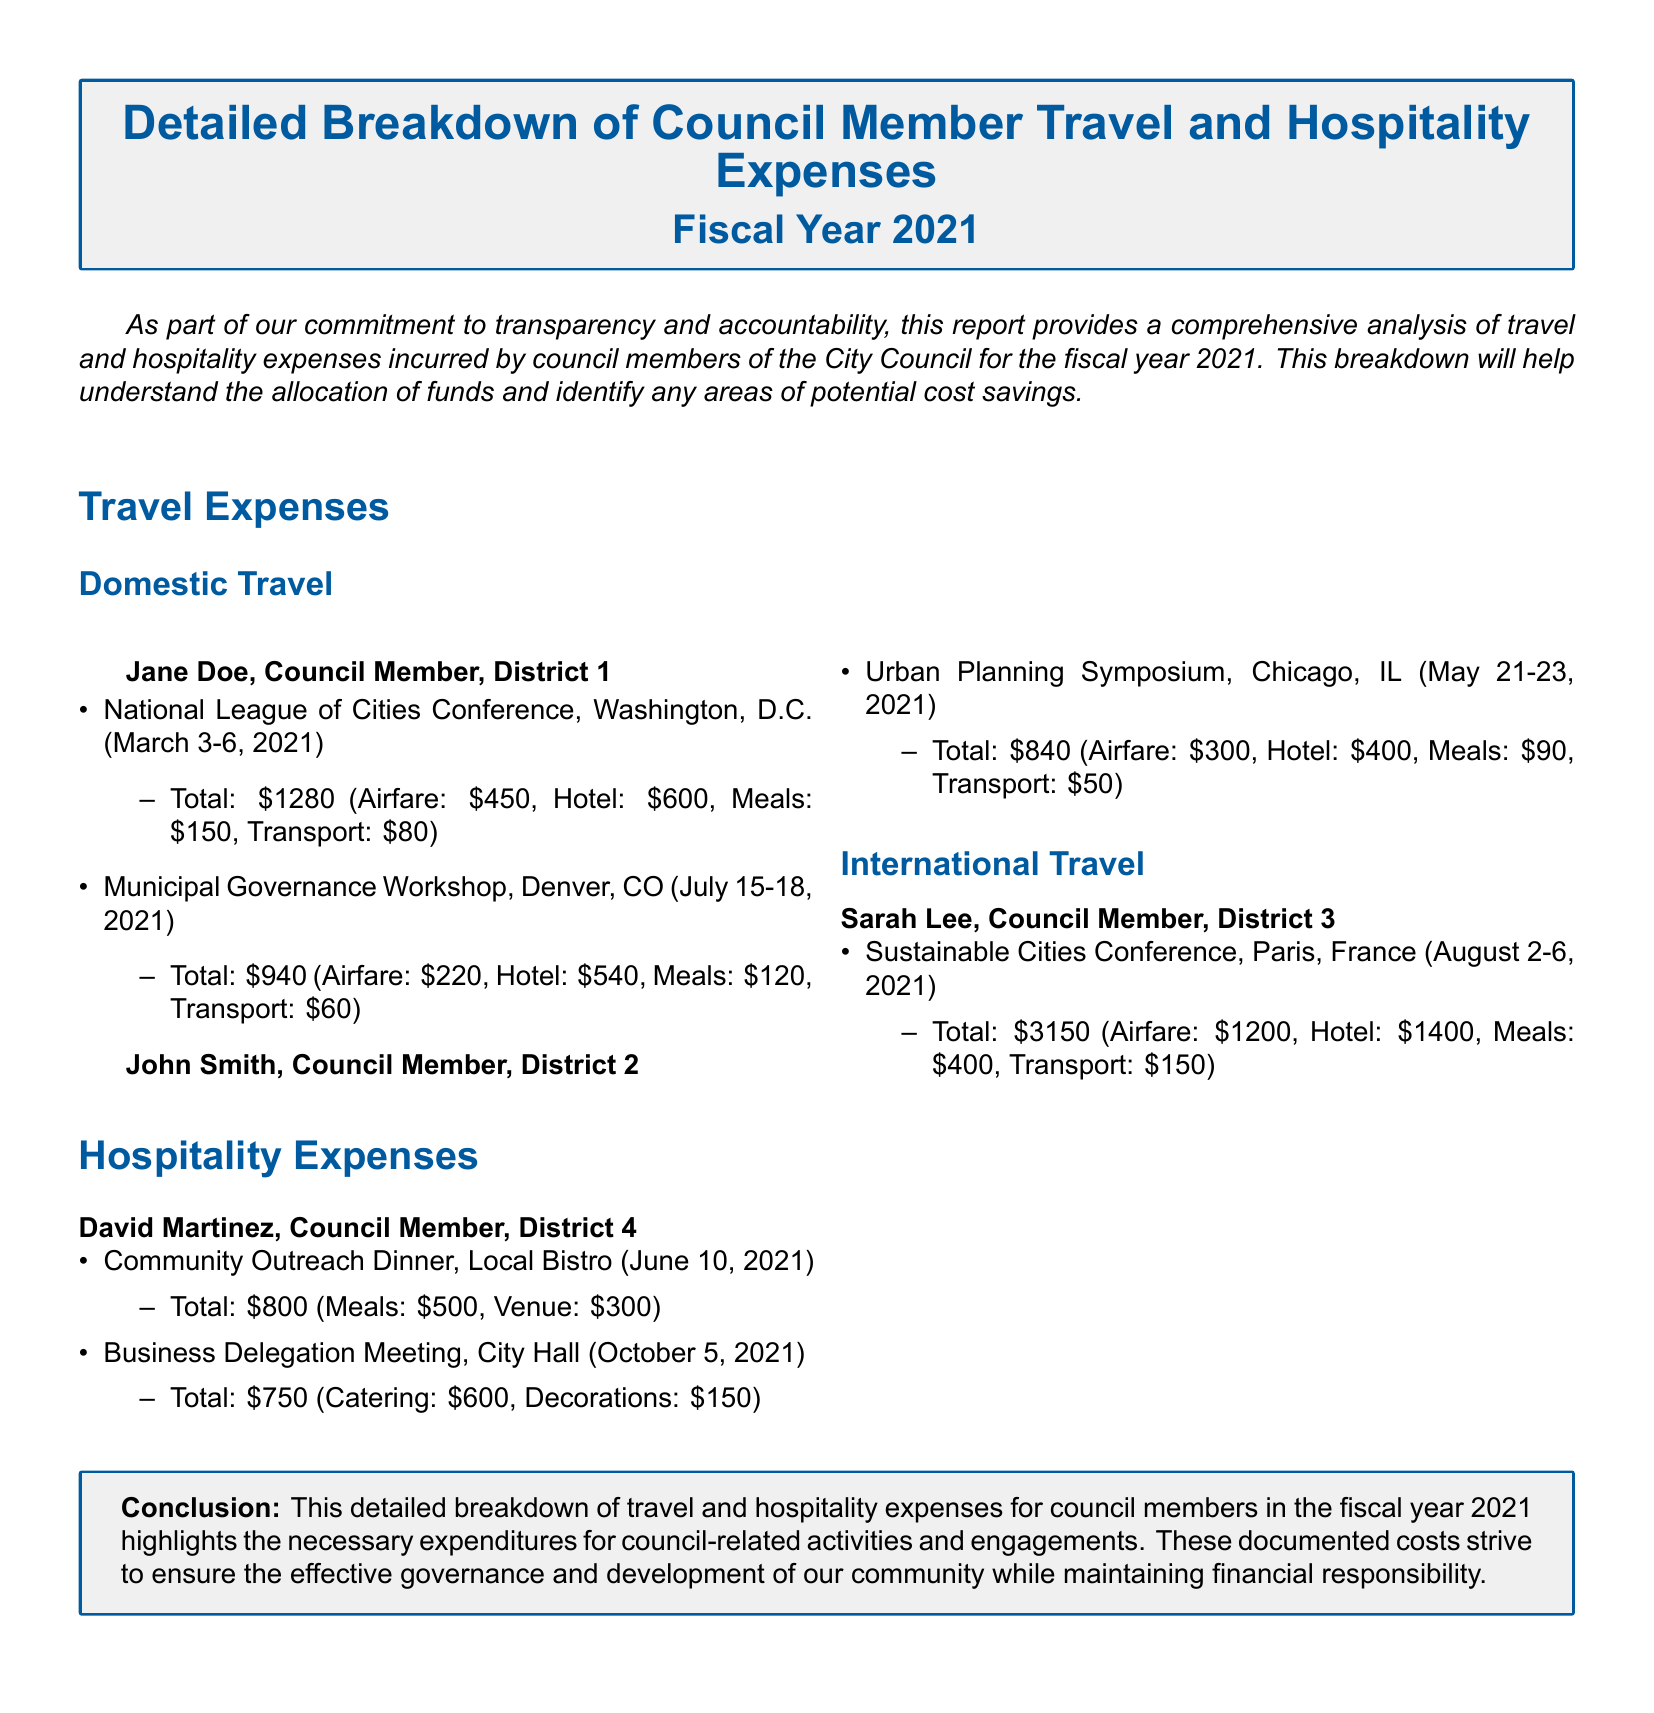What was the total amount spent by Jane Doe on domestic travel? The total amount spent by Jane Doe on domestic travel is the sum of her two listed trips: $1280 (National League of Cities Conference) + $940 (Municipal Governance Workshop) = $2220.
Answer: $2220 What was the airfare cost for Sarah Lee's trip? The airfare cost for Sarah Lee's trip to the Sustainable Cities Conference is stated as $1200.
Answer: $1200 How many council members are mentioned in the report? The report mentions four council members: Jane Doe, John Smith, Sarah Lee, and David Martinez.
Answer: Four What was the total cost for David Martinez's Community Outreach Dinner? The total cost for David Martinez's Community Outreach Dinner is $800, as outlined in the hospitality expenses section.
Answer: $800 Which council member attended the Urban Planning Symposium? The council member who attended the Urban Planning Symposium, held in Chicago, IL, is John Smith.
Answer: John Smith What date was the Business Delegation Meeting held? The Business Delegation Meeting was held on October 5, 2021, as indicated in the hospitality expenses section.
Answer: October 5, 2021 What was the total expense for the Sustainable Cities Conference? The total expense for Sarah Lee's attendance at the Sustainable Cities Conference is $3150, as detailed in the travel expenses section.
Answer: $3150 How many expenses did David Martinez incur for hospitality events? David Martinez incurred two expenses for hospitality events: one for the Community Outreach Dinner and another for the Business Delegation Meeting.
Answer: Two What is the primary purpose of the report? The primary purpose of the report is to provide transparency and accountability regarding council members' travel and hospitality expenses for the fiscal year 2021.
Answer: Transparency and accountability 